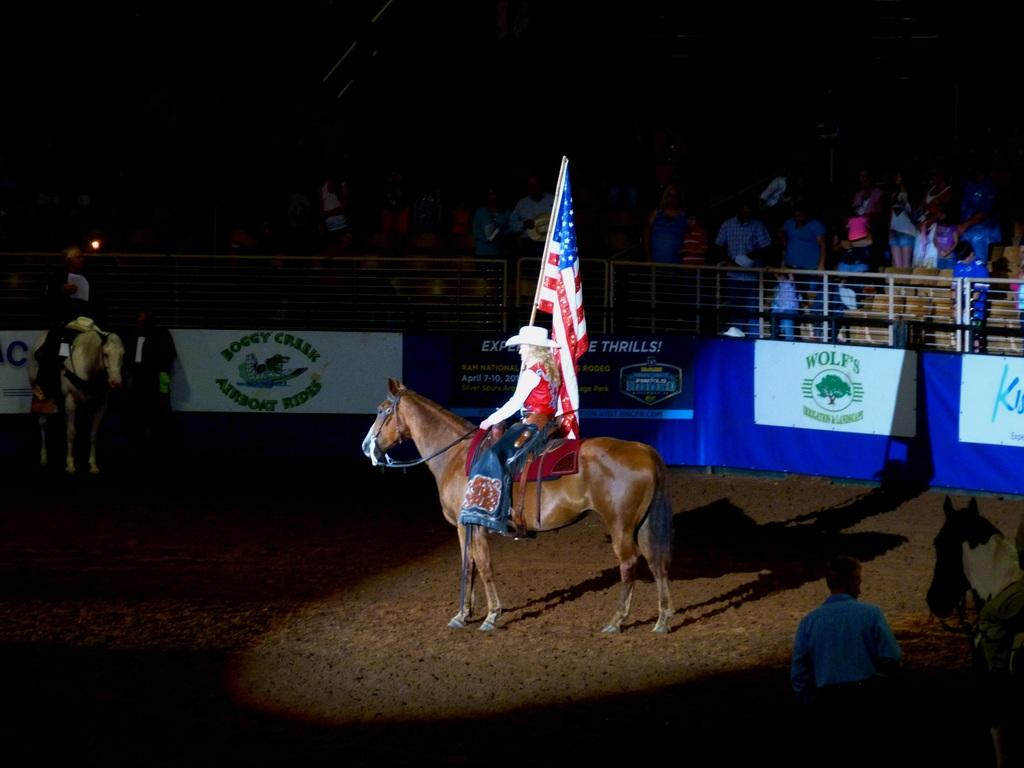What are the two persons in the image doing? The two persons are sitting on horses. What is the person holding in the image? The person is holding a flag. What else can be seen in the image besides the persons and horses? There are banners in the image. Can you describe the group of people in the image? There is a group of people in the image. What is the color of the background in the image? The background of the image is dark. What type of flock is visible in the image? There is no flock present in the image. What cast member is missing from the image? There is no reference to a cast or any specific individuals in the image, so it is not possible to determine if any cast member is missing. 